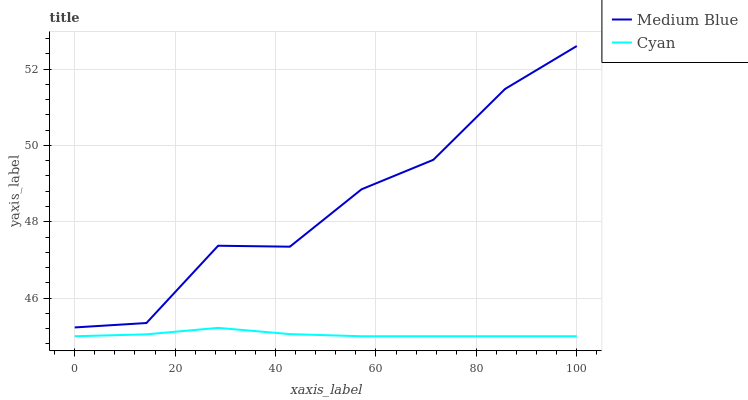Does Cyan have the minimum area under the curve?
Answer yes or no. Yes. Does Medium Blue have the maximum area under the curve?
Answer yes or no. Yes. Does Medium Blue have the minimum area under the curve?
Answer yes or no. No. Is Cyan the smoothest?
Answer yes or no. Yes. Is Medium Blue the roughest?
Answer yes or no. Yes. Is Medium Blue the smoothest?
Answer yes or no. No. Does Cyan have the lowest value?
Answer yes or no. Yes. Does Medium Blue have the lowest value?
Answer yes or no. No. Does Medium Blue have the highest value?
Answer yes or no. Yes. Is Cyan less than Medium Blue?
Answer yes or no. Yes. Is Medium Blue greater than Cyan?
Answer yes or no. Yes. Does Cyan intersect Medium Blue?
Answer yes or no. No. 